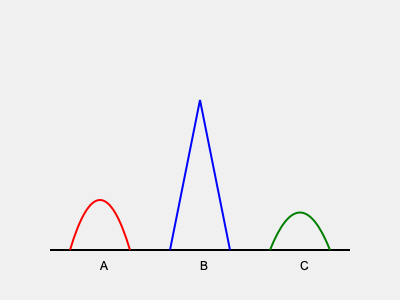In the image above, three silhouettes of theatrical costume designs are represented by curves A, B, and C. Which design would likely create the most dramatic visual impact on stage due to its angular and exaggerated shape? To answer this question, we need to analyze the characteristics of each silhouette:

1. Silhouette A (red curve):
   - Represents a rounded, soft shape
   - Has gentle curves and no sharp angles
   - Creates a more natural, flowing appearance

2. Silhouette B (blue line):
   - Consists of two straight lines meeting at a point
   - Forms a triangular shape with sharp angles
   - Creates a bold, geometric appearance

3. Silhouette C (green curve):
   - Has a slight S-curve shape
   - More defined than A, but less angular than B
   - Creates a subtle, elegant appearance

In theatrical costume design, angular and exaggerated shapes tend to create more dramatic visual impacts on stage. They stand out more prominently and can be easily perceived from a distance.

Among the three silhouettes, B is the most angular and exaggerated. Its sharp triangular shape would likely create the most striking visual effect on stage, drawing the audience's attention and contributing to the overall dramatic impact of the performance.

Silhouette A, being the softest and most rounded, would have the least dramatic impact. Silhouette C, while more defined than A, still lacks the bold angularity of B.
Answer: B 